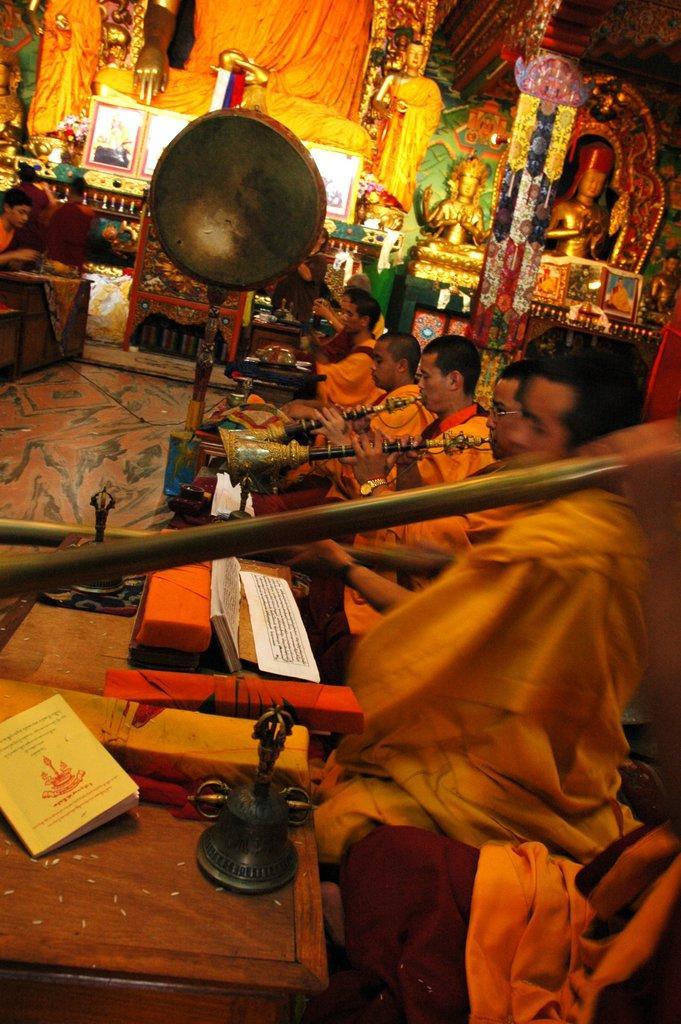In one or two sentences, can you explain what this image depicts? In the image on the right side there are many people sitting and playing musical instruments. In front of them there are tables with books and some other things. In the background there are many idols. And also there are few other things in the image. 